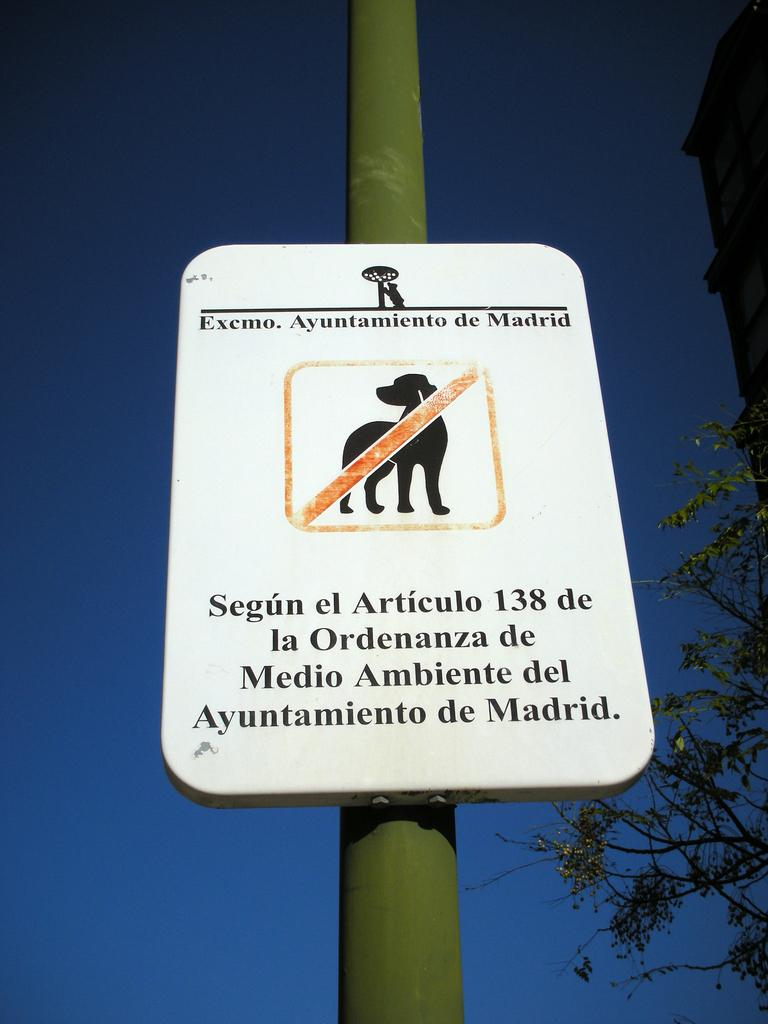What is attached to a pole in the image? There is a sign board attached to a pole in the image. What type of natural elements can be seen in the image? There are trees in the image. What type of man-made structures are visible in the image? There are buildings in the image. What is visible in the background of the image? The sky is visible in the image. What type of sponge is being used to clean the sign board in the image? There is no sponge present in the image, and the sign board is not being cleaned. 